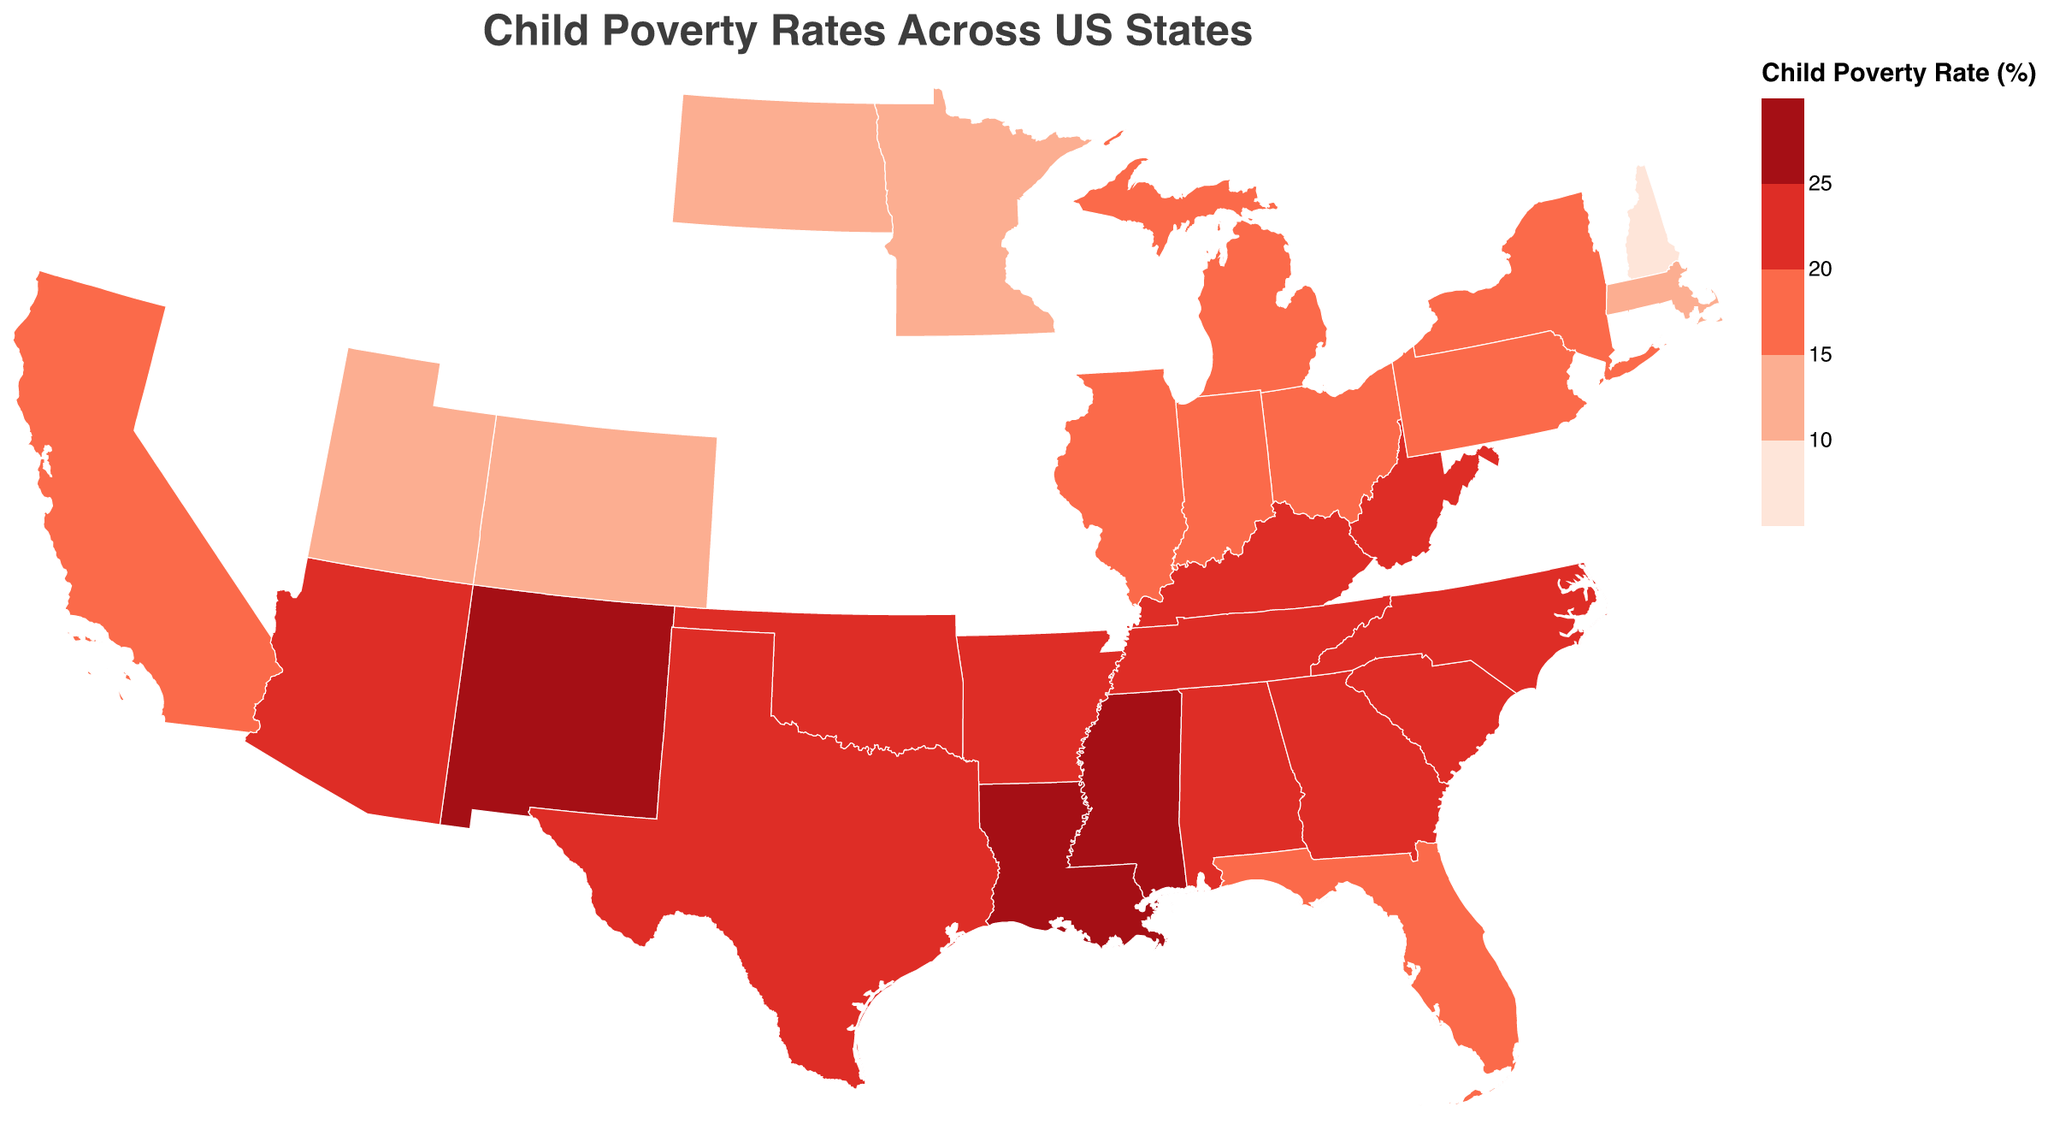What is the title of the figure? The title is generally found at the top of the figure, indicating the subject or focus of the plot. In this figure, it is clearly labeled.
Answer: Child Poverty Rates Across US States Which state has the highest child poverty rate? To find the highest rate, look at the state with the darkest color. The tooltip or legend will provide exact numbers. Mississippi shows the highest rate.
Answer: Mississippi Which state has the lowest child poverty rate? To find the lowest rate, look at the state with the lightest color. The tooltip indicates the exact number. New Hampshire has the lightest color and lowest rate.
Answer: New Hampshire What is the child poverty rate in California? Locate California on the map and read the tooltip or the legend coloration to get the rate. California is in a moderately less saturated color indicating a middle value.
Answer: 17.8% Compare the child poverty rates of Texas and Florida. How do they differ? Look at both states on the map and compare their colors and tooltip values. Texas has a poverty rate of 20.9% while Florida has 19.8%. Subtract Florida’s rate from Texas’s rate.
Answer: 1.1% What is the average child poverty rate of the three states with the lowest rates? Identify the three lightest states (New Hampshire, North Dakota, and Utah), sum their rates (8.6 + 10.2 + 10.4), and divide by 3.
Answer: 9.73% Are there any states in the top quartile (highest poverty rate) located in the northeast region of the US? Check the map for states in the northeast and see if their colors match the darkest shades indicating higher poverty rates. New York, Pennsylvania, and Massachusetts are in the northeast but have lower poverty rates.
Answer: No How many states have a child poverty rate greater than 20%? Count the states with colors above the 20% threshold in the legend. Children poverty rates over 20% are notable in 14 states.
Answer: 14 Which region in the US has more states with higher child poverty rates? Observe the geographic distribution of darker colors. The southern region, including states like Mississippi, Louisiana, and Alabama, has more states with higher poverty rates.
Answer: Southern region 